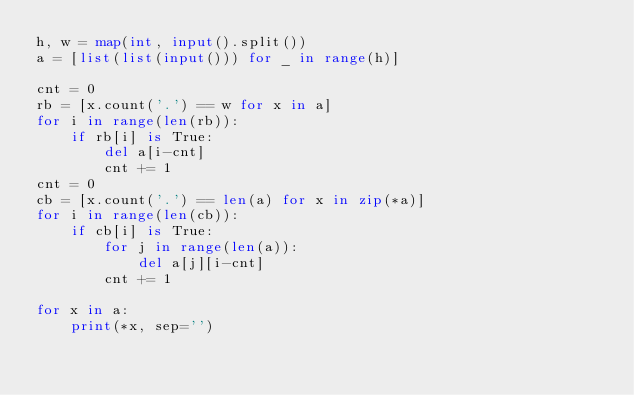Convert code to text. <code><loc_0><loc_0><loc_500><loc_500><_Python_>h, w = map(int, input().split())
a = [list(list(input())) for _ in range(h)]

cnt = 0
rb = [x.count('.') == w for x in a]
for i in range(len(rb)):
    if rb[i] is True:
        del a[i-cnt]
        cnt += 1
cnt = 0
cb = [x.count('.') == len(a) for x in zip(*a)]
for i in range(len(cb)):
    if cb[i] is True:
        for j in range(len(a)):
            del a[j][i-cnt]
        cnt += 1

for x in a:
    print(*x, sep='')
</code> 